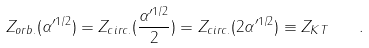<formula> <loc_0><loc_0><loc_500><loc_500>Z _ { o r b . } ( \alpha ^ { \prime 1 / 2 } ) = Z _ { c i r c . } ( { \frac { \alpha ^ { \prime 1 / 2 } } { 2 } } ) = Z _ { c i r c . } ( 2 \alpha ^ { \prime 1 / 2 } ) \equiv Z _ { K T } \quad .</formula> 